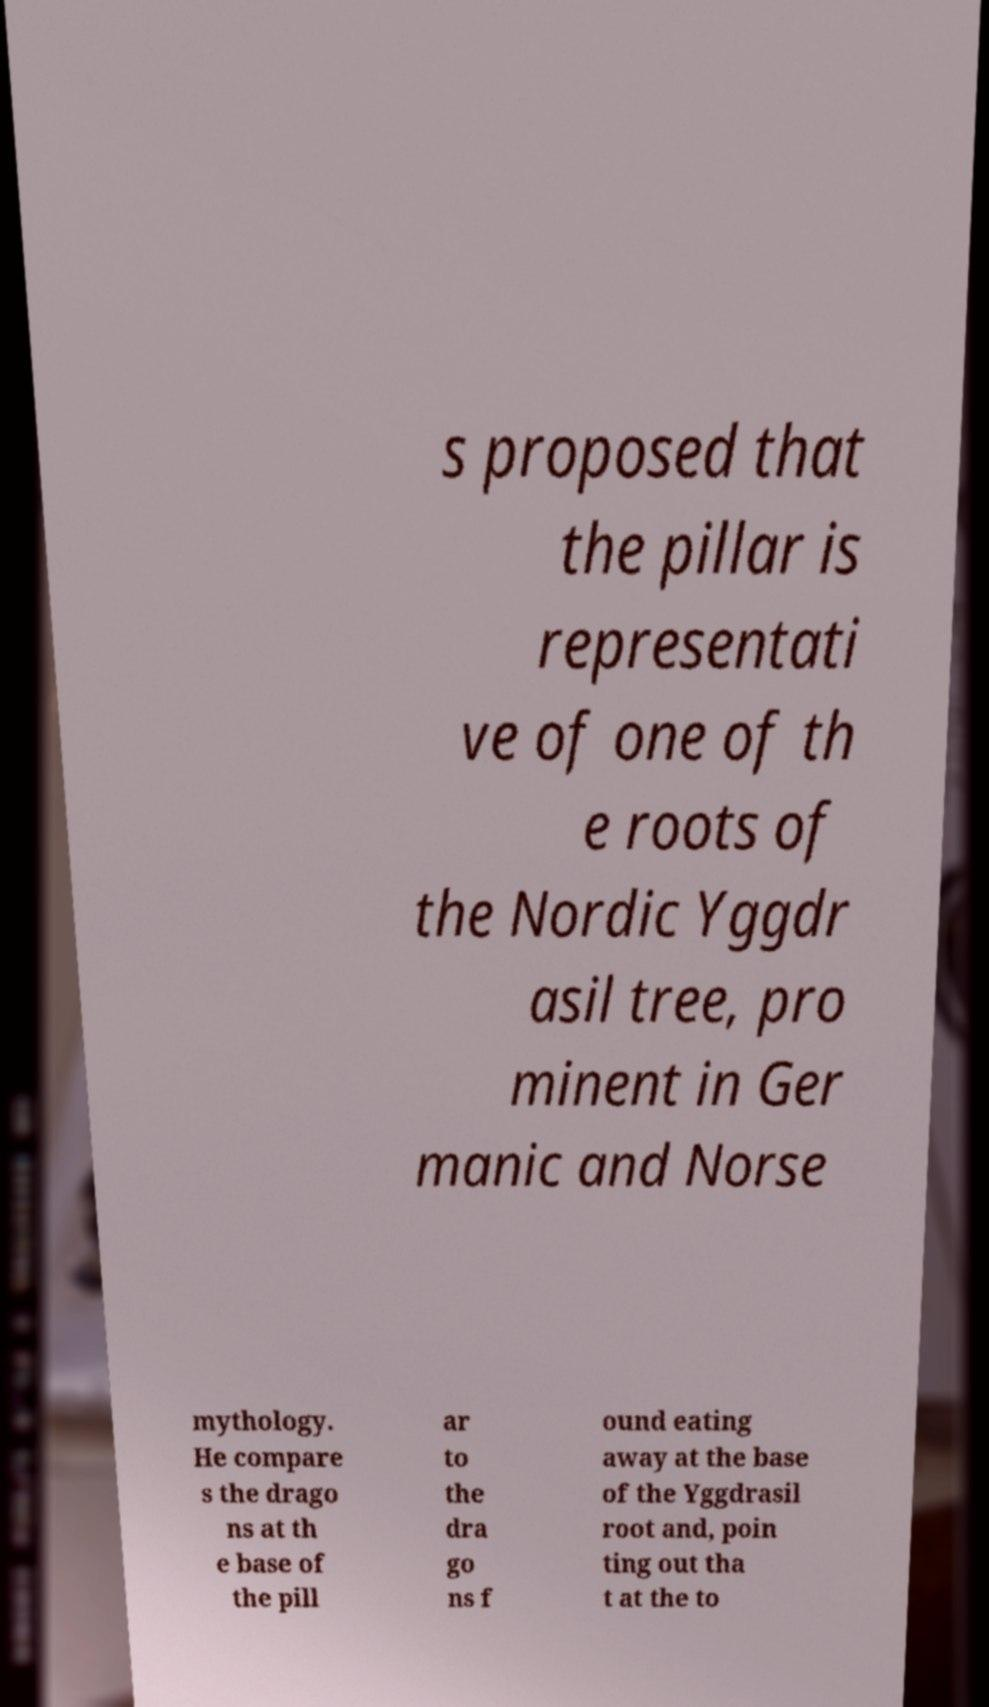For documentation purposes, I need the text within this image transcribed. Could you provide that? s proposed that the pillar is representati ve of one of th e roots of the Nordic Yggdr asil tree, pro minent in Ger manic and Norse mythology. He compare s the drago ns at th e base of the pill ar to the dra go ns f ound eating away at the base of the Yggdrasil root and, poin ting out tha t at the to 